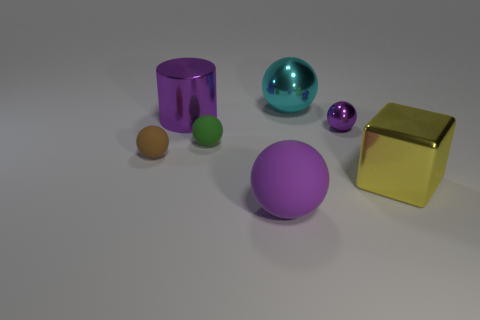Subtract all large shiny spheres. How many spheres are left? 4 Subtract all yellow balls. Subtract all blue cylinders. How many balls are left? 5 Add 2 small cyan matte spheres. How many objects exist? 9 Subtract all cubes. How many objects are left? 6 Subtract 1 yellow blocks. How many objects are left? 6 Subtract all purple rubber spheres. Subtract all tiny matte spheres. How many objects are left? 4 Add 2 green matte balls. How many green matte balls are left? 3 Add 6 big blocks. How many big blocks exist? 7 